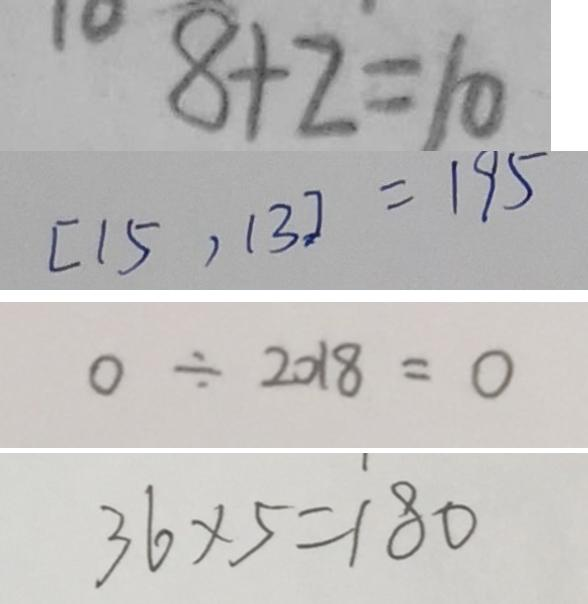Convert formula to latex. <formula><loc_0><loc_0><loc_500><loc_500>8 + 2 = 1 0 
 [ 1 5 , 1 3 ] = 1 9 5 
 0 \div 2 0 1 8 = 0 
 3 6 \times 5 = 1 8 0</formula> 